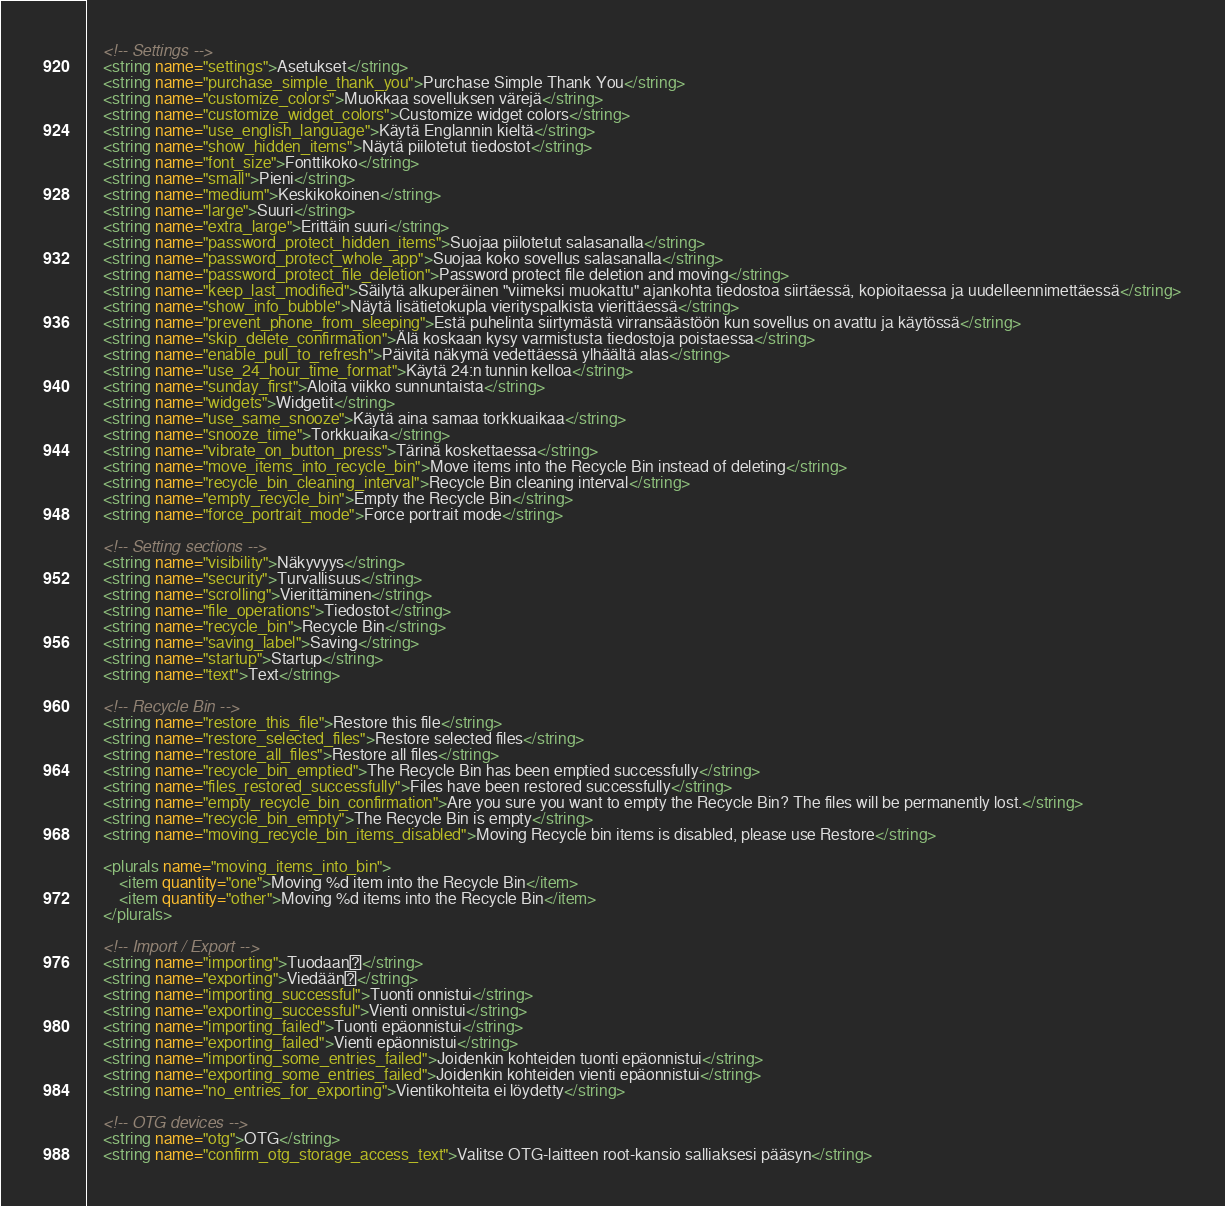<code> <loc_0><loc_0><loc_500><loc_500><_XML_>    <!-- Settings -->
    <string name="settings">Asetukset</string>
    <string name="purchase_simple_thank_you">Purchase Simple Thank You</string>
    <string name="customize_colors">Muokkaa sovelluksen värejä</string>
    <string name="customize_widget_colors">Customize widget colors</string>
    <string name="use_english_language">Käytä Englannin kieltä</string>
    <string name="show_hidden_items">Näytä piilotetut tiedostot</string>
    <string name="font_size">Fonttikoko</string>
    <string name="small">Pieni</string>
    <string name="medium">Keskikokoinen</string>
    <string name="large">Suuri</string>
    <string name="extra_large">Erittäin suuri</string>
    <string name="password_protect_hidden_items">Suojaa piilotetut salasanalla</string>
    <string name="password_protect_whole_app">Suojaa koko sovellus salasanalla</string>
    <string name="password_protect_file_deletion">Password protect file deletion and moving</string>
    <string name="keep_last_modified">Säilytä alkuperäinen "viimeksi muokattu" ajankohta tiedostoa siirtäessä, kopioitaessa ja uudelleennimettäessä</string>
    <string name="show_info_bubble">Näytä lisätietokupla vierityspalkista vierittäessä</string>
    <string name="prevent_phone_from_sleeping">Estä puhelinta siirtymästä virransäästöön kun sovellus on avattu ja käytössä</string>
    <string name="skip_delete_confirmation">Älä koskaan kysy varmistusta tiedostoja poistaessa</string>
    <string name="enable_pull_to_refresh">Päivitä näkymä vedettäessä ylhäältä alas</string>
    <string name="use_24_hour_time_format">Käytä 24:n tunnin kelloa</string>
    <string name="sunday_first">Aloita viikko sunnuntaista</string>
    <string name="widgets">Widgetit</string>
    <string name="use_same_snooze">Käytä aina samaa torkkuaikaa</string>
    <string name="snooze_time">Torkkuaika</string>
    <string name="vibrate_on_button_press">Tärinä koskettaessa</string>
    <string name="move_items_into_recycle_bin">Move items into the Recycle Bin instead of deleting</string>
    <string name="recycle_bin_cleaning_interval">Recycle Bin cleaning interval</string>
    <string name="empty_recycle_bin">Empty the Recycle Bin</string>
    <string name="force_portrait_mode">Force portrait mode</string>

    <!-- Setting sections -->
    <string name="visibility">Näkyvyys</string>
    <string name="security">Turvallisuus</string>
    <string name="scrolling">Vierittäminen</string>
    <string name="file_operations">Tiedostot</string>
    <string name="recycle_bin">Recycle Bin</string>
    <string name="saving_label">Saving</string>
    <string name="startup">Startup</string>
    <string name="text">Text</string>

    <!-- Recycle Bin -->
    <string name="restore_this_file">Restore this file</string>
    <string name="restore_selected_files">Restore selected files</string>
    <string name="restore_all_files">Restore all files</string>
    <string name="recycle_bin_emptied">The Recycle Bin has been emptied successfully</string>
    <string name="files_restored_successfully">Files have been restored successfully</string>
    <string name="empty_recycle_bin_confirmation">Are you sure you want to empty the Recycle Bin? The files will be permanently lost.</string>
    <string name="recycle_bin_empty">The Recycle Bin is empty</string>
    <string name="moving_recycle_bin_items_disabled">Moving Recycle bin items is disabled, please use Restore</string>

    <plurals name="moving_items_into_bin">
        <item quantity="one">Moving %d item into the Recycle Bin</item>
        <item quantity="other">Moving %d items into the Recycle Bin</item>
    </plurals>

    <!-- Import / Export -->
    <string name="importing">Tuodaan</string>
    <string name="exporting">Viedään</string>
    <string name="importing_successful">Tuonti onnistui</string>
    <string name="exporting_successful">Vienti onnistui</string>
    <string name="importing_failed">Tuonti epäonnistui</string>
    <string name="exporting_failed">Vienti epäonnistui</string>
    <string name="importing_some_entries_failed">Joidenkin kohteiden tuonti epäonnistui</string>
    <string name="exporting_some_entries_failed">Joidenkin kohteiden vienti epäonnistui</string>
    <string name="no_entries_for_exporting">Vientikohteita ei löydetty</string>

    <!-- OTG devices -->
    <string name="otg">OTG</string>
    <string name="confirm_otg_storage_access_text">Valitse OTG-laitteen root-kansio salliaksesi pääsyn</string></code> 